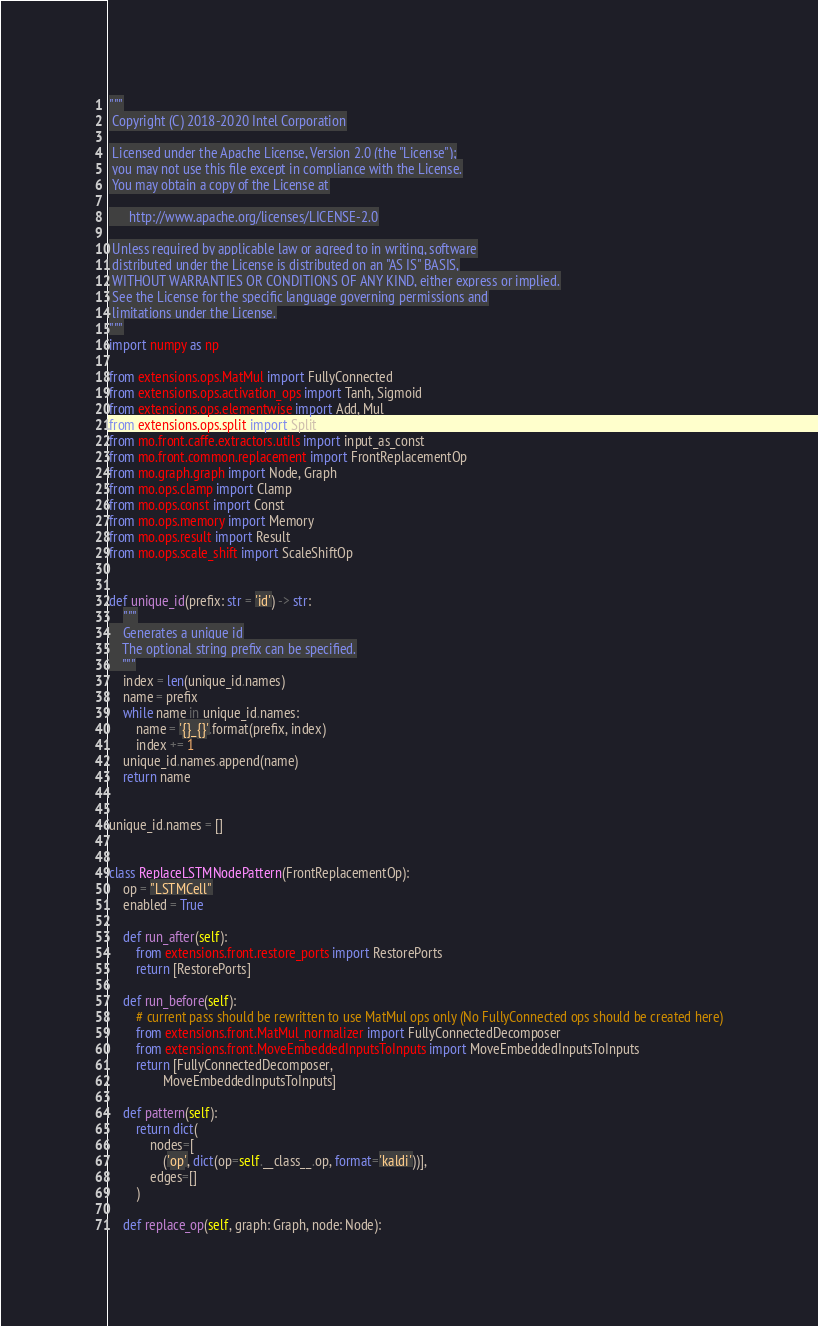Convert code to text. <code><loc_0><loc_0><loc_500><loc_500><_Python_>"""
 Copyright (C) 2018-2020 Intel Corporation

 Licensed under the Apache License, Version 2.0 (the "License");
 you may not use this file except in compliance with the License.
 You may obtain a copy of the License at

      http://www.apache.org/licenses/LICENSE-2.0

 Unless required by applicable law or agreed to in writing, software
 distributed under the License is distributed on an "AS IS" BASIS,
 WITHOUT WARRANTIES OR CONDITIONS OF ANY KIND, either express or implied.
 See the License for the specific language governing permissions and
 limitations under the License.
"""
import numpy as np

from extensions.ops.MatMul import FullyConnected
from extensions.ops.activation_ops import Tanh, Sigmoid
from extensions.ops.elementwise import Add, Mul
from extensions.ops.split import Split
from mo.front.caffe.extractors.utils import input_as_const
from mo.front.common.replacement import FrontReplacementOp
from mo.graph.graph import Node, Graph
from mo.ops.clamp import Clamp
from mo.ops.const import Const
from mo.ops.memory import Memory
from mo.ops.result import Result
from mo.ops.scale_shift import ScaleShiftOp


def unique_id(prefix: str = 'id') -> str:
    """
    Generates a unique id
    The optional string prefix can be specified.
    """
    index = len(unique_id.names)
    name = prefix
    while name in unique_id.names:
        name = '{}_{}'.format(prefix, index)
        index += 1
    unique_id.names.append(name)
    return name


unique_id.names = []


class ReplaceLSTMNodePattern(FrontReplacementOp):
    op = "LSTMCell"
    enabled = True

    def run_after(self):
        from extensions.front.restore_ports import RestorePorts
        return [RestorePorts]

    def run_before(self):
        # current pass should be rewritten to use MatMul ops only (No FullyConnected ops should be created here)
        from extensions.front.MatMul_normalizer import FullyConnectedDecomposer
        from extensions.front.MoveEmbeddedInputsToInputs import MoveEmbeddedInputsToInputs
        return [FullyConnectedDecomposer,
                MoveEmbeddedInputsToInputs]

    def pattern(self):
        return dict(
            nodes=[
                ('op', dict(op=self.__class__.op, format='kaldi'))],
            edges=[]
        )

    def replace_op(self, graph: Graph, node: Node):</code> 